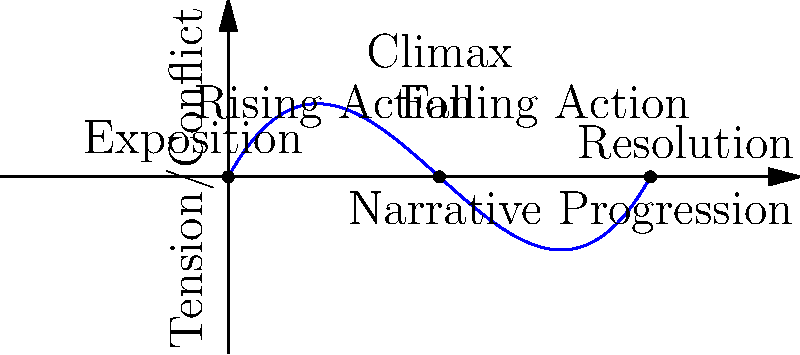Analyze the plot diagram above, which represents a typical narrative arc in C.S. Lewis's works. How does this structure contribute to the development of his themes, and at which point in the arc do you think Lewis often introduces his most profound spiritual insights? 1. Recognize the plot diagram: The graph shows a classic narrative arc with five main stages: Exposition, Rising Action, Climax, Falling Action, and Resolution.

2. Understand C.S. Lewis's narrative style:
   a. Exposition: Lewis often begins by introducing characters and setting, often in a mundane or familiar context.
   b. Rising Action: He gradually introduces fantastical elements or spiritual challenges, building tension.
   c. Climax: This is typically where the main character faces their greatest challenge, often with spiritual significance.
   d. Falling Action: The consequences of the climax unfold, often involving character growth or revelation.
   e. Resolution: Lewis frequently ties the story back to reality, often with a changed perspective.

3. Analyze theme development:
   - The gradual rise in tension allows Lewis to slowly introduce and develop his themes, often related to faith, morality, and personal growth.
   - The climax usually represents a critical moment of choice or realization for the characters, embodying the core theme.

4. Identify the point of profound spiritual insights:
   - While Lewis weaves spiritual elements throughout his narratives, the most profound insights often occur at or immediately after the climax.
   - This placement allows characters (and readers) to experience a transformative moment at the height of tension, followed by reflection and application during the falling action and resolution.

5. Consider examples from Lewis's works:
   - In "The Lion, the Witch, and the Wardrobe," Aslan's sacrifice and resurrection occur at the climax, embodying themes of redemption and faith.
   - In "The Great Divorce," the protagonist's most significant realizations about the nature of heaven and hell occur near the story's peak.
Answer: At or immediately after the climax, allowing for transformative experiences at peak tension followed by reflection. 